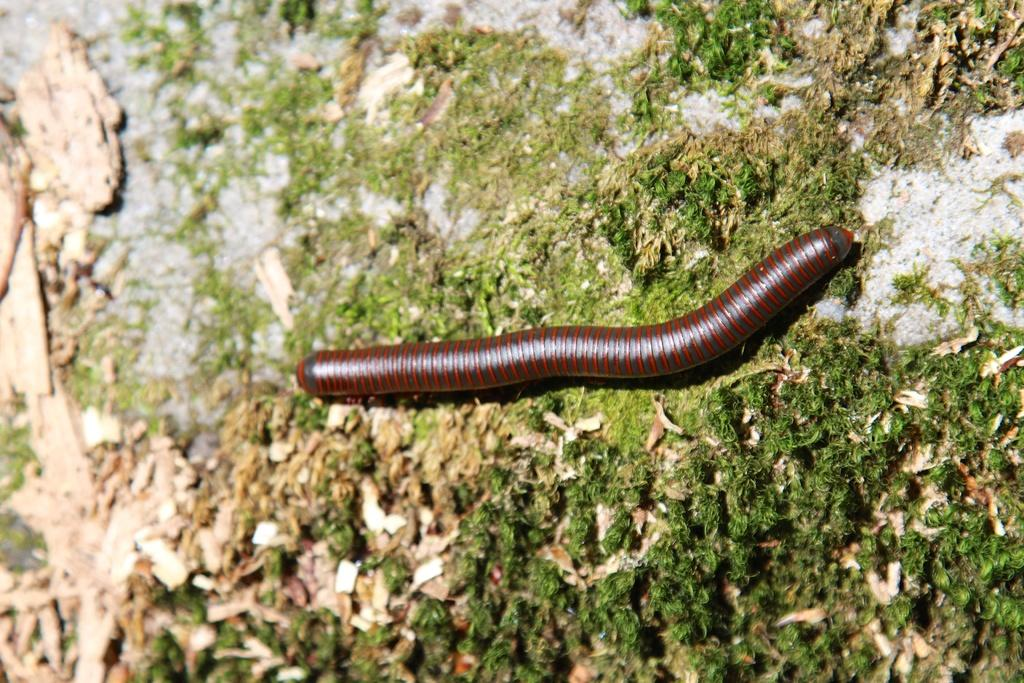What type of creature is on the ground in the image? There is a worm on the ground in the image. What type of lace can be seen on the worm in the image? There is no lace present on the worm in the image. How many stars are visible in the image? There are no stars visible in the image, as it is focused on a worm on the ground. 